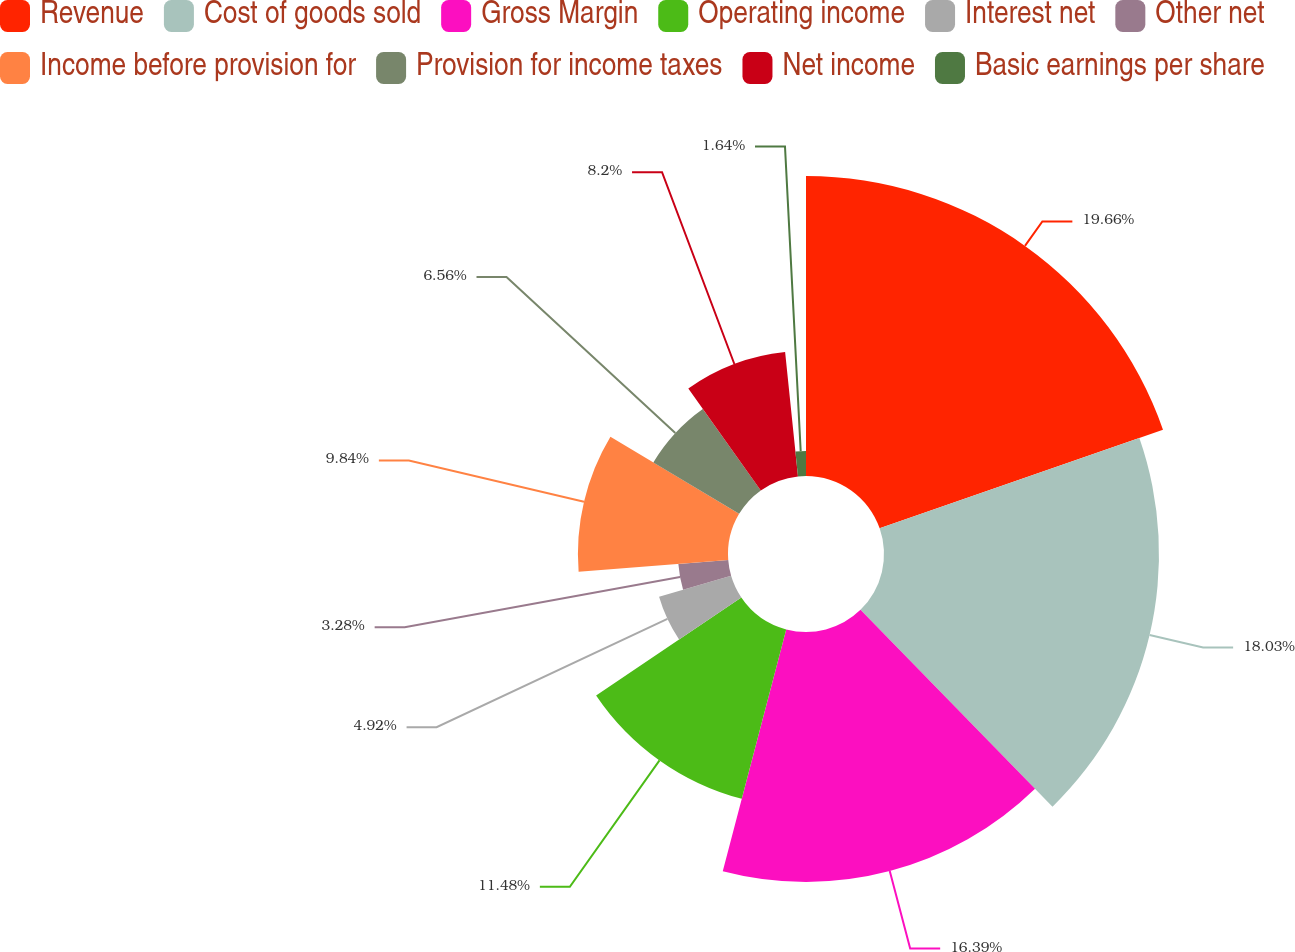Convert chart. <chart><loc_0><loc_0><loc_500><loc_500><pie_chart><fcel>Revenue<fcel>Cost of goods sold<fcel>Gross Margin<fcel>Operating income<fcel>Interest net<fcel>Other net<fcel>Income before provision for<fcel>Provision for income taxes<fcel>Net income<fcel>Basic earnings per share<nl><fcel>19.67%<fcel>18.03%<fcel>16.39%<fcel>11.48%<fcel>4.92%<fcel>3.28%<fcel>9.84%<fcel>6.56%<fcel>8.2%<fcel>1.64%<nl></chart> 